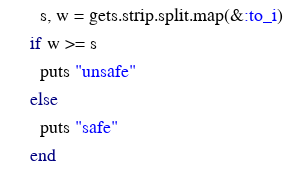Convert code to text. <code><loc_0><loc_0><loc_500><loc_500><_Ruby_>	s, w = gets.strip.split.map(&:to_i)
  if w >= s
    puts "unsafe"
  else
    puts "safe"
  end
</code> 